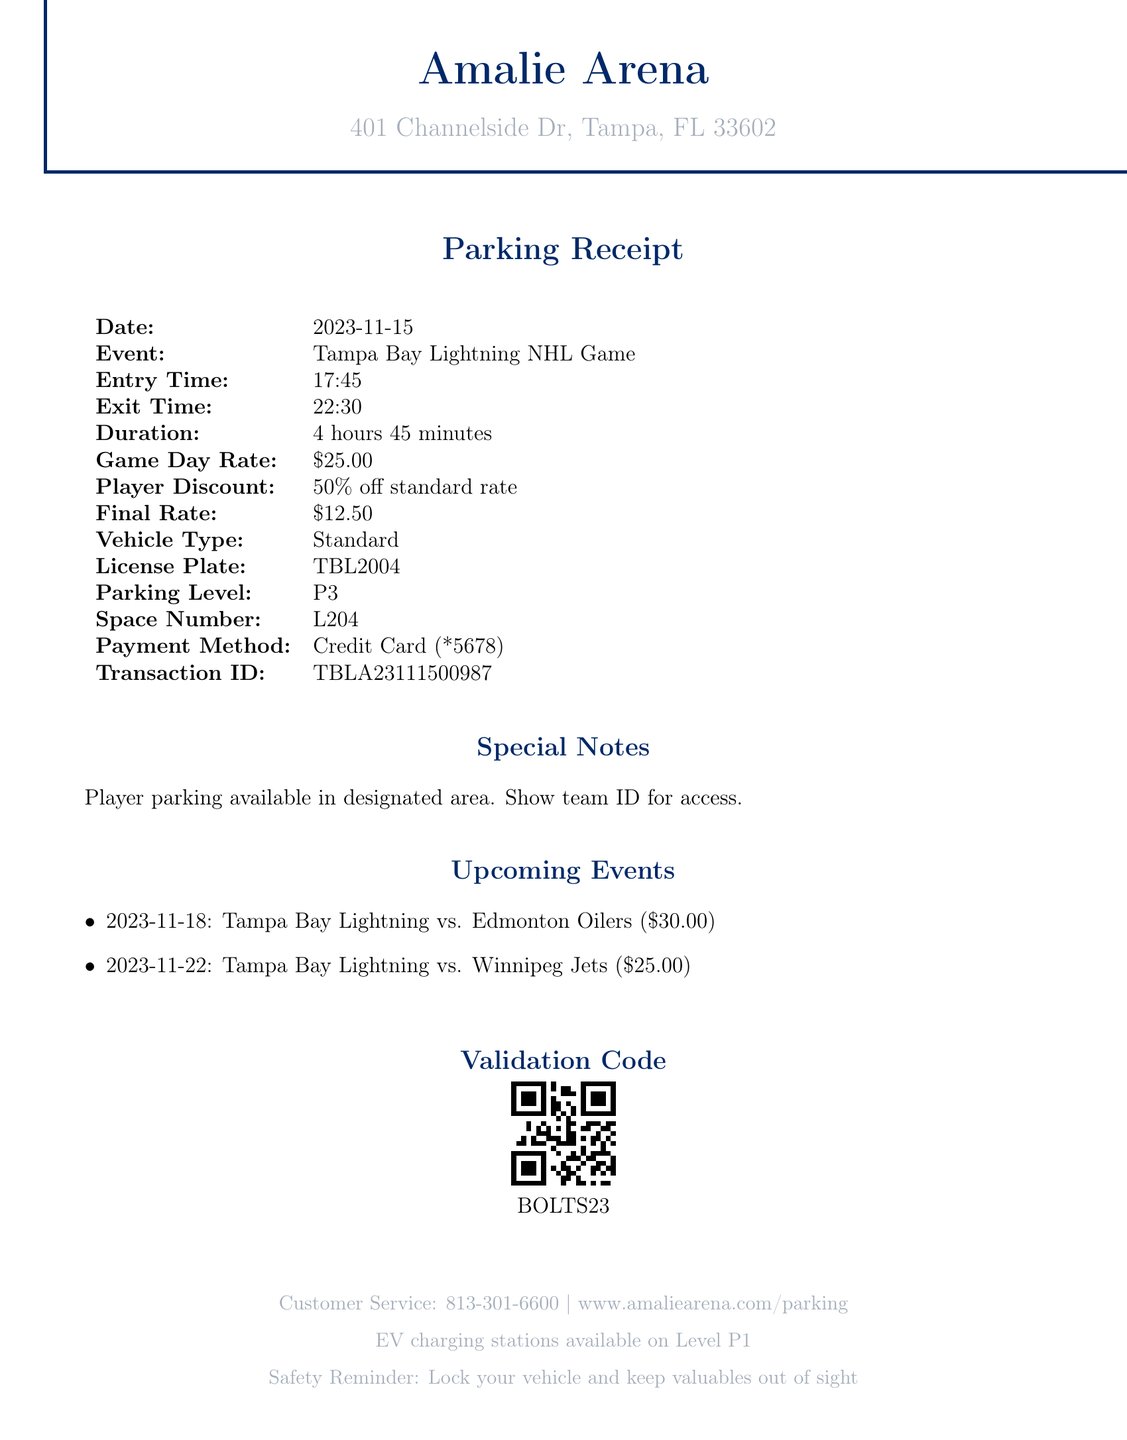What is the venue name? The venue name is provided at the top of the receipt, listed as Amalie Arena.
Answer: Amalie Arena What is the game day rate for parking? The game day rate is stated clearly in the document under parking fees, which is $25.00.
Answer: $25.00 What is the duration of the parking? The duration is listed as the time from entry to exit, which is 4 hours 45 minutes.
Answer: 4 hours 45 minutes What is the validation code? The validation code is the code given for automated payment at exit, which is BOLTS23.
Answer: BOLTS23 What is the final rate after applying the player discount? The final rate reflects the discounted amount for players, which is 50% off the standard rate, resulting in $12.50.
Answer: $12.50 How many upcoming events are listed? The document specifies two upcoming events that are mentioned under "Upcoming Events."
Answer: 2 What vehicle type is parked? The vehicle type is categorized in the document, identified as Standard.
Answer: Standard What is the license plate number? The document lists the license plate number clearly as TBL2004.
Answer: TBL2004 What time does the event start? The entry time provided in the document indicates when the event begins, showing 17:45.
Answer: 17:45 